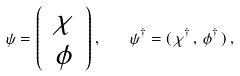<formula> <loc_0><loc_0><loc_500><loc_500>\psi = { \left ( \begin{array} { c } \, \chi \, \\ \phi \end{array} \right ) } \, , \quad \psi ^ { \dagger } = ( \, \chi ^ { \dagger } \, , \, \phi ^ { \dagger } \, ) \, ,</formula> 